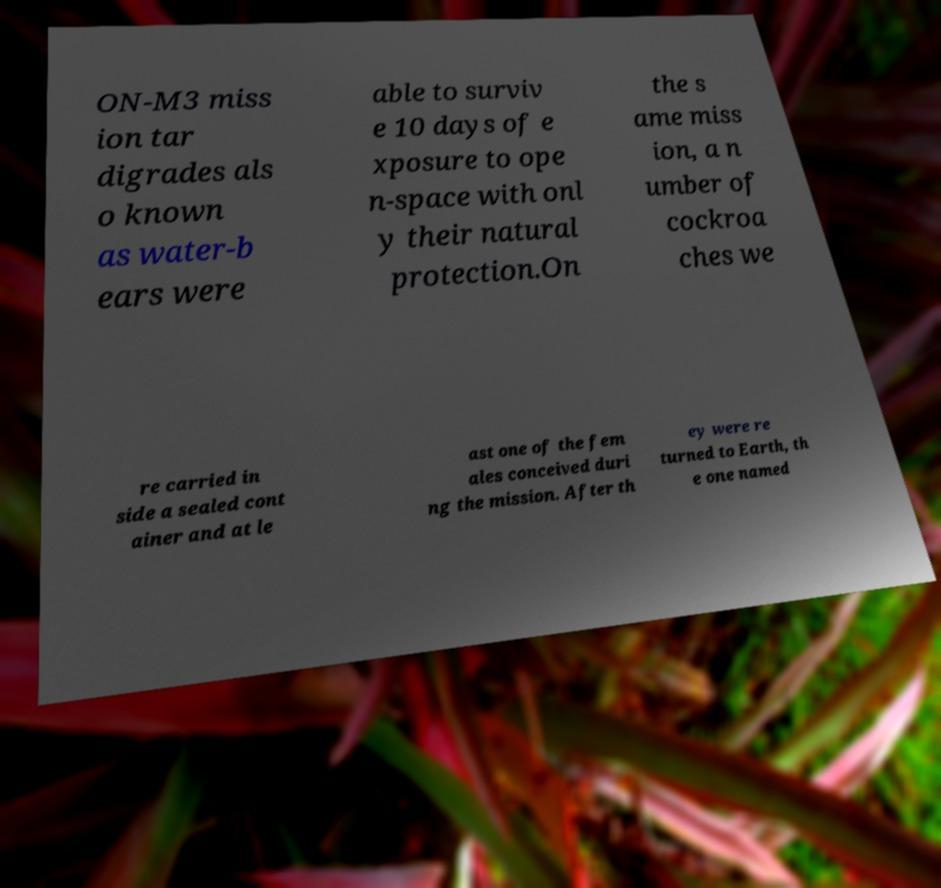For documentation purposes, I need the text within this image transcribed. Could you provide that? ON-M3 miss ion tar digrades als o known as water-b ears were able to surviv e 10 days of e xposure to ope n-space with onl y their natural protection.On the s ame miss ion, a n umber of cockroa ches we re carried in side a sealed cont ainer and at le ast one of the fem ales conceived duri ng the mission. After th ey were re turned to Earth, th e one named 